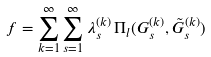<formula> <loc_0><loc_0><loc_500><loc_500>f = \sum _ { k = 1 } ^ { \infty } \sum _ { s = 1 } ^ { \infty } \lambda _ { s } ^ { ( k ) } \, \Pi _ { l } ( G _ { s } ^ { ( k ) } , \tilde { G } _ { s } ^ { ( k ) } )</formula> 